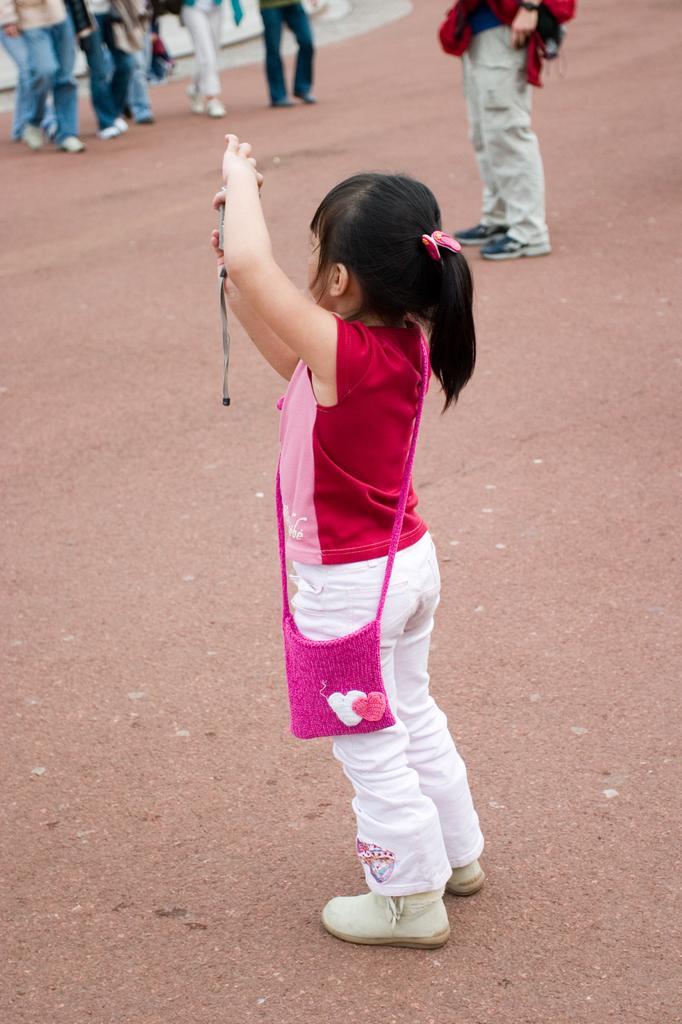How would you summarize this image in a sentence or two? In this picture we can see a girl in the red and pink t shirt is standing on the path and in front of the girl there are groups of people walking and a person is standing. 